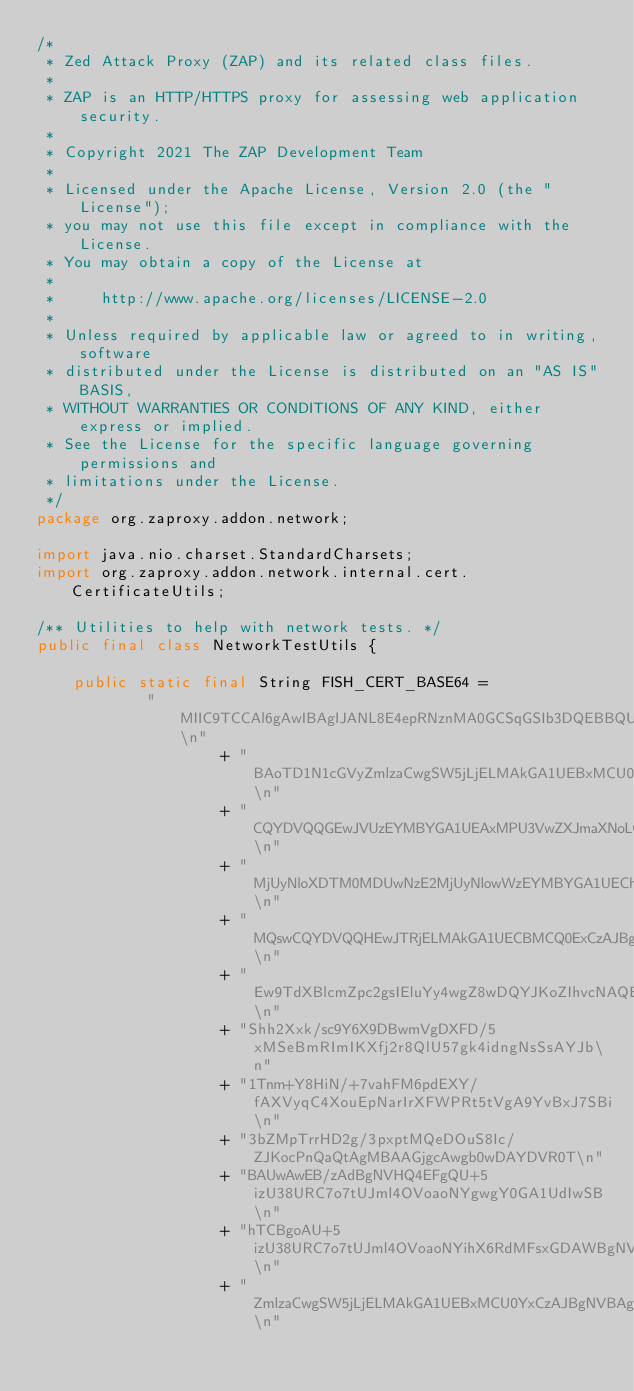<code> <loc_0><loc_0><loc_500><loc_500><_Java_>/*
 * Zed Attack Proxy (ZAP) and its related class files.
 *
 * ZAP is an HTTP/HTTPS proxy for assessing web application security.
 *
 * Copyright 2021 The ZAP Development Team
 *
 * Licensed under the Apache License, Version 2.0 (the "License");
 * you may not use this file except in compliance with the License.
 * You may obtain a copy of the License at
 *
 *     http://www.apache.org/licenses/LICENSE-2.0
 *
 * Unless required by applicable law or agreed to in writing, software
 * distributed under the License is distributed on an "AS IS" BASIS,
 * WITHOUT WARRANTIES OR CONDITIONS OF ANY KIND, either express or implied.
 * See the License for the specific language governing permissions and
 * limitations under the License.
 */
package org.zaproxy.addon.network;

import java.nio.charset.StandardCharsets;
import org.zaproxy.addon.network.internal.cert.CertificateUtils;

/** Utilities to help with network tests. */
public final class NetworkTestUtils {

    public static final String FISH_CERT_BASE64 =
            "MIIC9TCCAl6gAwIBAgIJANL8E4epRNznMA0GCSqGSIb3DQEBBQUAMFsxGDAWBgNV\n"
                    + "BAoTD1N1cGVyZmlzaCwgSW5jLjELMAkGA1UEBxMCU0YxCzAJBgNVBAgTAkNBMQsw\n"
                    + "CQYDVQQGEwJVUzEYMBYGA1UEAxMPU3VwZXJmaXNoLCBJbmMuMB4XDTE0MDUxMjE2\n"
                    + "MjUyNloXDTM0MDUwNzE2MjUyNlowWzEYMBYGA1UEChMPU3VwZXJmaXNoLCBJbmMu\n"
                    + "MQswCQYDVQQHEwJTRjELMAkGA1UECBMCQ0ExCzAJBgNVBAYTAlVTMRgwFgYDVQQD\n"
                    + "Ew9TdXBlcmZpc2gsIEluYy4wgZ8wDQYJKoZIhvcNAQEBBQADgY0AMIGJAoGBAOjz\n"
                    + "Shh2Xxk/sc9Y6X9DBwmVgDXFD/5xMSeBmRImIKXfj2r8QlU57gk4idngNsSsAYJb\n"
                    + "1Tnm+Y8HiN/+7vahFM6pdEXY/fAXVyqC4XouEpNarIrXFWPRt5tVgA9YvBxJ7SBi\n"
                    + "3bZMpTrrHD2g/3pxptMQeDOuS8Ic/ZJKocPnQaQtAgMBAAGjgcAwgb0wDAYDVR0T\n"
                    + "BAUwAwEB/zAdBgNVHQ4EFgQU+5izU38URC7o7tUJml4OVoaoNYgwgY0GA1UdIwSB\n"
                    + "hTCBgoAU+5izU38URC7o7tUJml4OVoaoNYihX6RdMFsxGDAWBgNVBAoTD1N1cGVy\n"
                    + "ZmlzaCwgSW5jLjELMAkGA1UEBxMCU0YxCzAJBgNVBAgTAkNBMQswCQYDVQQGEwJV\n"</code> 